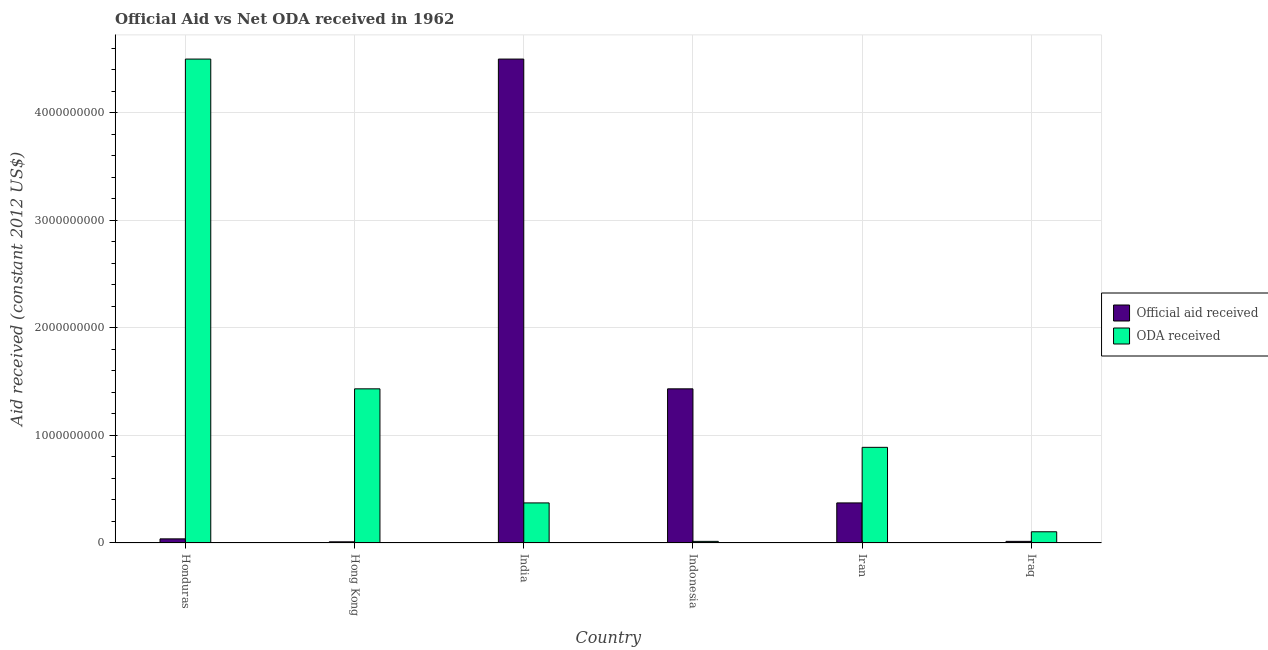How many different coloured bars are there?
Provide a short and direct response. 2. How many bars are there on the 3rd tick from the left?
Provide a succinct answer. 2. How many bars are there on the 3rd tick from the right?
Make the answer very short. 2. What is the label of the 6th group of bars from the left?
Offer a terse response. Iraq. In how many cases, is the number of bars for a given country not equal to the number of legend labels?
Give a very brief answer. 0. What is the official aid received in India?
Ensure brevity in your answer.  4.50e+09. Across all countries, what is the maximum official aid received?
Your answer should be compact. 4.50e+09. Across all countries, what is the minimum official aid received?
Offer a terse response. 1.08e+07. In which country was the official aid received minimum?
Provide a succinct answer. Hong Kong. What is the total oda received in the graph?
Offer a terse response. 7.31e+09. What is the difference between the official aid received in Indonesia and that in Iraq?
Ensure brevity in your answer.  1.42e+09. What is the difference between the official aid received in Indonesia and the oda received in Iraq?
Provide a succinct answer. 1.33e+09. What is the average official aid received per country?
Give a very brief answer. 1.06e+09. What is the difference between the oda received and official aid received in Iraq?
Make the answer very short. 8.92e+07. In how many countries, is the official aid received greater than 4200000000 US$?
Offer a terse response. 1. What is the ratio of the official aid received in India to that in Iraq?
Your answer should be very brief. 297.36. Is the difference between the official aid received in Hong Kong and Iraq greater than the difference between the oda received in Hong Kong and Iraq?
Offer a terse response. No. What is the difference between the highest and the second highest oda received?
Ensure brevity in your answer.  3.07e+09. What is the difference between the highest and the lowest oda received?
Provide a short and direct response. 4.48e+09. In how many countries, is the official aid received greater than the average official aid received taken over all countries?
Offer a very short reply. 2. Is the sum of the official aid received in Honduras and Iran greater than the maximum oda received across all countries?
Make the answer very short. No. What does the 1st bar from the left in Honduras represents?
Your answer should be very brief. Official aid received. What does the 1st bar from the right in India represents?
Keep it short and to the point. ODA received. How many bars are there?
Offer a terse response. 12. Are all the bars in the graph horizontal?
Offer a terse response. No. How many countries are there in the graph?
Give a very brief answer. 6. What is the difference between two consecutive major ticks on the Y-axis?
Keep it short and to the point. 1.00e+09. Does the graph contain any zero values?
Ensure brevity in your answer.  No. Does the graph contain grids?
Keep it short and to the point. Yes. Where does the legend appear in the graph?
Your answer should be compact. Center right. How are the legend labels stacked?
Provide a short and direct response. Vertical. What is the title of the graph?
Offer a terse response. Official Aid vs Net ODA received in 1962 . What is the label or title of the Y-axis?
Provide a succinct answer. Aid received (constant 2012 US$). What is the Aid received (constant 2012 US$) of Official aid received in Honduras?
Ensure brevity in your answer.  3.84e+07. What is the Aid received (constant 2012 US$) in ODA received in Honduras?
Make the answer very short. 4.50e+09. What is the Aid received (constant 2012 US$) in Official aid received in Hong Kong?
Give a very brief answer. 1.08e+07. What is the Aid received (constant 2012 US$) of ODA received in Hong Kong?
Give a very brief answer. 1.43e+09. What is the Aid received (constant 2012 US$) in Official aid received in India?
Offer a terse response. 4.50e+09. What is the Aid received (constant 2012 US$) of ODA received in India?
Keep it short and to the point. 3.73e+08. What is the Aid received (constant 2012 US$) of Official aid received in Indonesia?
Provide a succinct answer. 1.43e+09. What is the Aid received (constant 2012 US$) in ODA received in Indonesia?
Provide a succinct answer. 1.51e+07. What is the Aid received (constant 2012 US$) of Official aid received in Iran?
Your answer should be compact. 3.73e+08. What is the Aid received (constant 2012 US$) in ODA received in Iran?
Your answer should be compact. 8.89e+08. What is the Aid received (constant 2012 US$) of Official aid received in Iraq?
Keep it short and to the point. 1.51e+07. What is the Aid received (constant 2012 US$) of ODA received in Iraq?
Your answer should be very brief. 1.04e+08. Across all countries, what is the maximum Aid received (constant 2012 US$) in Official aid received?
Offer a terse response. 4.50e+09. Across all countries, what is the maximum Aid received (constant 2012 US$) of ODA received?
Make the answer very short. 4.50e+09. Across all countries, what is the minimum Aid received (constant 2012 US$) of Official aid received?
Ensure brevity in your answer.  1.08e+07. Across all countries, what is the minimum Aid received (constant 2012 US$) in ODA received?
Offer a terse response. 1.51e+07. What is the total Aid received (constant 2012 US$) of Official aid received in the graph?
Your answer should be very brief. 6.37e+09. What is the total Aid received (constant 2012 US$) in ODA received in the graph?
Provide a short and direct response. 7.31e+09. What is the difference between the Aid received (constant 2012 US$) of Official aid received in Honduras and that in Hong Kong?
Provide a succinct answer. 2.75e+07. What is the difference between the Aid received (constant 2012 US$) in ODA received in Honduras and that in Hong Kong?
Offer a terse response. 3.07e+09. What is the difference between the Aid received (constant 2012 US$) in Official aid received in Honduras and that in India?
Offer a very short reply. -4.46e+09. What is the difference between the Aid received (constant 2012 US$) of ODA received in Honduras and that in India?
Ensure brevity in your answer.  4.13e+09. What is the difference between the Aid received (constant 2012 US$) in Official aid received in Honduras and that in Indonesia?
Provide a short and direct response. -1.39e+09. What is the difference between the Aid received (constant 2012 US$) in ODA received in Honduras and that in Indonesia?
Offer a very short reply. 4.48e+09. What is the difference between the Aid received (constant 2012 US$) of Official aid received in Honduras and that in Iran?
Your answer should be compact. -3.34e+08. What is the difference between the Aid received (constant 2012 US$) of ODA received in Honduras and that in Iran?
Offer a very short reply. 3.61e+09. What is the difference between the Aid received (constant 2012 US$) in Official aid received in Honduras and that in Iraq?
Ensure brevity in your answer.  2.32e+07. What is the difference between the Aid received (constant 2012 US$) in ODA received in Honduras and that in Iraq?
Ensure brevity in your answer.  4.39e+09. What is the difference between the Aid received (constant 2012 US$) of Official aid received in Hong Kong and that in India?
Provide a short and direct response. -4.49e+09. What is the difference between the Aid received (constant 2012 US$) of ODA received in Hong Kong and that in India?
Give a very brief answer. 1.06e+09. What is the difference between the Aid received (constant 2012 US$) of Official aid received in Hong Kong and that in Indonesia?
Your answer should be very brief. -1.42e+09. What is the difference between the Aid received (constant 2012 US$) in ODA received in Hong Kong and that in Indonesia?
Provide a succinct answer. 1.42e+09. What is the difference between the Aid received (constant 2012 US$) of Official aid received in Hong Kong and that in Iran?
Ensure brevity in your answer.  -3.62e+08. What is the difference between the Aid received (constant 2012 US$) in ODA received in Hong Kong and that in Iran?
Your answer should be very brief. 5.44e+08. What is the difference between the Aid received (constant 2012 US$) in Official aid received in Hong Kong and that in Iraq?
Your response must be concise. -4.31e+06. What is the difference between the Aid received (constant 2012 US$) in ODA received in Hong Kong and that in Iraq?
Give a very brief answer. 1.33e+09. What is the difference between the Aid received (constant 2012 US$) in Official aid received in India and that in Indonesia?
Offer a very short reply. 3.07e+09. What is the difference between the Aid received (constant 2012 US$) of ODA received in India and that in Indonesia?
Your response must be concise. 3.57e+08. What is the difference between the Aid received (constant 2012 US$) in Official aid received in India and that in Iran?
Your response must be concise. 4.13e+09. What is the difference between the Aid received (constant 2012 US$) of ODA received in India and that in Iran?
Make the answer very short. -5.17e+08. What is the difference between the Aid received (constant 2012 US$) in Official aid received in India and that in Iraq?
Offer a very short reply. 4.48e+09. What is the difference between the Aid received (constant 2012 US$) in ODA received in India and that in Iraq?
Ensure brevity in your answer.  2.68e+08. What is the difference between the Aid received (constant 2012 US$) of Official aid received in Indonesia and that in Iran?
Your answer should be compact. 1.06e+09. What is the difference between the Aid received (constant 2012 US$) of ODA received in Indonesia and that in Iran?
Your answer should be very brief. -8.74e+08. What is the difference between the Aid received (constant 2012 US$) of Official aid received in Indonesia and that in Iraq?
Your answer should be compact. 1.42e+09. What is the difference between the Aid received (constant 2012 US$) in ODA received in Indonesia and that in Iraq?
Ensure brevity in your answer.  -8.92e+07. What is the difference between the Aid received (constant 2012 US$) of Official aid received in Iran and that in Iraq?
Make the answer very short. 3.57e+08. What is the difference between the Aid received (constant 2012 US$) in ODA received in Iran and that in Iraq?
Offer a very short reply. 7.85e+08. What is the difference between the Aid received (constant 2012 US$) in Official aid received in Honduras and the Aid received (constant 2012 US$) in ODA received in Hong Kong?
Provide a short and direct response. -1.39e+09. What is the difference between the Aid received (constant 2012 US$) in Official aid received in Honduras and the Aid received (constant 2012 US$) in ODA received in India?
Keep it short and to the point. -3.34e+08. What is the difference between the Aid received (constant 2012 US$) of Official aid received in Honduras and the Aid received (constant 2012 US$) of ODA received in Indonesia?
Give a very brief answer. 2.32e+07. What is the difference between the Aid received (constant 2012 US$) of Official aid received in Honduras and the Aid received (constant 2012 US$) of ODA received in Iran?
Make the answer very short. -8.51e+08. What is the difference between the Aid received (constant 2012 US$) of Official aid received in Honduras and the Aid received (constant 2012 US$) of ODA received in Iraq?
Give a very brief answer. -6.59e+07. What is the difference between the Aid received (constant 2012 US$) in Official aid received in Hong Kong and the Aid received (constant 2012 US$) in ODA received in India?
Offer a terse response. -3.62e+08. What is the difference between the Aid received (constant 2012 US$) in Official aid received in Hong Kong and the Aid received (constant 2012 US$) in ODA received in Indonesia?
Your answer should be compact. -4.31e+06. What is the difference between the Aid received (constant 2012 US$) of Official aid received in Hong Kong and the Aid received (constant 2012 US$) of ODA received in Iran?
Your answer should be compact. -8.78e+08. What is the difference between the Aid received (constant 2012 US$) of Official aid received in Hong Kong and the Aid received (constant 2012 US$) of ODA received in Iraq?
Your response must be concise. -9.35e+07. What is the difference between the Aid received (constant 2012 US$) in Official aid received in India and the Aid received (constant 2012 US$) in ODA received in Indonesia?
Ensure brevity in your answer.  4.48e+09. What is the difference between the Aid received (constant 2012 US$) of Official aid received in India and the Aid received (constant 2012 US$) of ODA received in Iran?
Offer a very short reply. 3.61e+09. What is the difference between the Aid received (constant 2012 US$) of Official aid received in India and the Aid received (constant 2012 US$) of ODA received in Iraq?
Ensure brevity in your answer.  4.39e+09. What is the difference between the Aid received (constant 2012 US$) in Official aid received in Indonesia and the Aid received (constant 2012 US$) in ODA received in Iran?
Your answer should be compact. 5.44e+08. What is the difference between the Aid received (constant 2012 US$) in Official aid received in Indonesia and the Aid received (constant 2012 US$) in ODA received in Iraq?
Provide a short and direct response. 1.33e+09. What is the difference between the Aid received (constant 2012 US$) in Official aid received in Iran and the Aid received (constant 2012 US$) in ODA received in Iraq?
Your answer should be compact. 2.68e+08. What is the average Aid received (constant 2012 US$) in Official aid received per country?
Offer a very short reply. 1.06e+09. What is the average Aid received (constant 2012 US$) of ODA received per country?
Ensure brevity in your answer.  1.22e+09. What is the difference between the Aid received (constant 2012 US$) in Official aid received and Aid received (constant 2012 US$) in ODA received in Honduras?
Offer a very short reply. -4.46e+09. What is the difference between the Aid received (constant 2012 US$) in Official aid received and Aid received (constant 2012 US$) in ODA received in Hong Kong?
Give a very brief answer. -1.42e+09. What is the difference between the Aid received (constant 2012 US$) in Official aid received and Aid received (constant 2012 US$) in ODA received in India?
Ensure brevity in your answer.  4.13e+09. What is the difference between the Aid received (constant 2012 US$) in Official aid received and Aid received (constant 2012 US$) in ODA received in Indonesia?
Provide a succinct answer. 1.42e+09. What is the difference between the Aid received (constant 2012 US$) of Official aid received and Aid received (constant 2012 US$) of ODA received in Iran?
Give a very brief answer. -5.17e+08. What is the difference between the Aid received (constant 2012 US$) of Official aid received and Aid received (constant 2012 US$) of ODA received in Iraq?
Make the answer very short. -8.92e+07. What is the ratio of the Aid received (constant 2012 US$) of Official aid received in Honduras to that in Hong Kong?
Make the answer very short. 3.55. What is the ratio of the Aid received (constant 2012 US$) of ODA received in Honduras to that in Hong Kong?
Provide a succinct answer. 3.14. What is the ratio of the Aid received (constant 2012 US$) of Official aid received in Honduras to that in India?
Keep it short and to the point. 0.01. What is the ratio of the Aid received (constant 2012 US$) of ODA received in Honduras to that in India?
Your response must be concise. 12.08. What is the ratio of the Aid received (constant 2012 US$) of Official aid received in Honduras to that in Indonesia?
Your answer should be compact. 0.03. What is the ratio of the Aid received (constant 2012 US$) of ODA received in Honduras to that in Indonesia?
Your response must be concise. 297.36. What is the ratio of the Aid received (constant 2012 US$) in Official aid received in Honduras to that in Iran?
Make the answer very short. 0.1. What is the ratio of the Aid received (constant 2012 US$) in ODA received in Honduras to that in Iran?
Your response must be concise. 5.06. What is the ratio of the Aid received (constant 2012 US$) of Official aid received in Honduras to that in Iraq?
Your answer should be very brief. 2.54. What is the ratio of the Aid received (constant 2012 US$) of ODA received in Honduras to that in Iraq?
Keep it short and to the point. 43.14. What is the ratio of the Aid received (constant 2012 US$) of Official aid received in Hong Kong to that in India?
Provide a short and direct response. 0. What is the ratio of the Aid received (constant 2012 US$) of ODA received in Hong Kong to that in India?
Make the answer very short. 3.85. What is the ratio of the Aid received (constant 2012 US$) in Official aid received in Hong Kong to that in Indonesia?
Give a very brief answer. 0.01. What is the ratio of the Aid received (constant 2012 US$) of ODA received in Hong Kong to that in Indonesia?
Your response must be concise. 94.72. What is the ratio of the Aid received (constant 2012 US$) of Official aid received in Hong Kong to that in Iran?
Your response must be concise. 0.03. What is the ratio of the Aid received (constant 2012 US$) of ODA received in Hong Kong to that in Iran?
Offer a terse response. 1.61. What is the ratio of the Aid received (constant 2012 US$) in Official aid received in Hong Kong to that in Iraq?
Give a very brief answer. 0.72. What is the ratio of the Aid received (constant 2012 US$) in ODA received in Hong Kong to that in Iraq?
Offer a very short reply. 13.74. What is the ratio of the Aid received (constant 2012 US$) in Official aid received in India to that in Indonesia?
Provide a succinct answer. 3.14. What is the ratio of the Aid received (constant 2012 US$) of ODA received in India to that in Indonesia?
Keep it short and to the point. 24.62. What is the ratio of the Aid received (constant 2012 US$) of Official aid received in India to that in Iran?
Give a very brief answer. 12.08. What is the ratio of the Aid received (constant 2012 US$) of ODA received in India to that in Iran?
Provide a succinct answer. 0.42. What is the ratio of the Aid received (constant 2012 US$) of Official aid received in India to that in Iraq?
Offer a very short reply. 297.36. What is the ratio of the Aid received (constant 2012 US$) of ODA received in India to that in Iraq?
Ensure brevity in your answer.  3.57. What is the ratio of the Aid received (constant 2012 US$) in Official aid received in Indonesia to that in Iran?
Keep it short and to the point. 3.85. What is the ratio of the Aid received (constant 2012 US$) of ODA received in Indonesia to that in Iran?
Your answer should be very brief. 0.02. What is the ratio of the Aid received (constant 2012 US$) in Official aid received in Indonesia to that in Iraq?
Ensure brevity in your answer.  94.72. What is the ratio of the Aid received (constant 2012 US$) of ODA received in Indonesia to that in Iraq?
Provide a succinct answer. 0.15. What is the ratio of the Aid received (constant 2012 US$) of Official aid received in Iran to that in Iraq?
Ensure brevity in your answer.  24.62. What is the ratio of the Aid received (constant 2012 US$) of ODA received in Iran to that in Iraq?
Provide a short and direct response. 8.53. What is the difference between the highest and the second highest Aid received (constant 2012 US$) of Official aid received?
Offer a very short reply. 3.07e+09. What is the difference between the highest and the second highest Aid received (constant 2012 US$) of ODA received?
Your answer should be very brief. 3.07e+09. What is the difference between the highest and the lowest Aid received (constant 2012 US$) of Official aid received?
Make the answer very short. 4.49e+09. What is the difference between the highest and the lowest Aid received (constant 2012 US$) in ODA received?
Keep it short and to the point. 4.48e+09. 